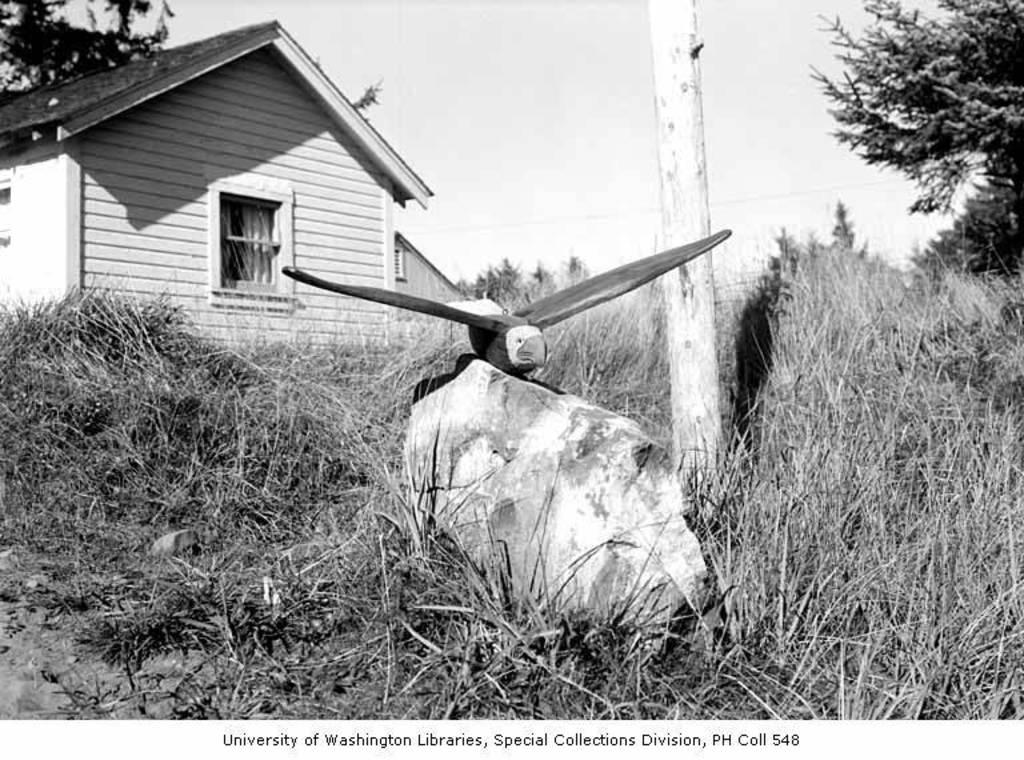<image>
Provide a brief description of the given image. The Special Collections Division made a beautiful model of an eagle. 